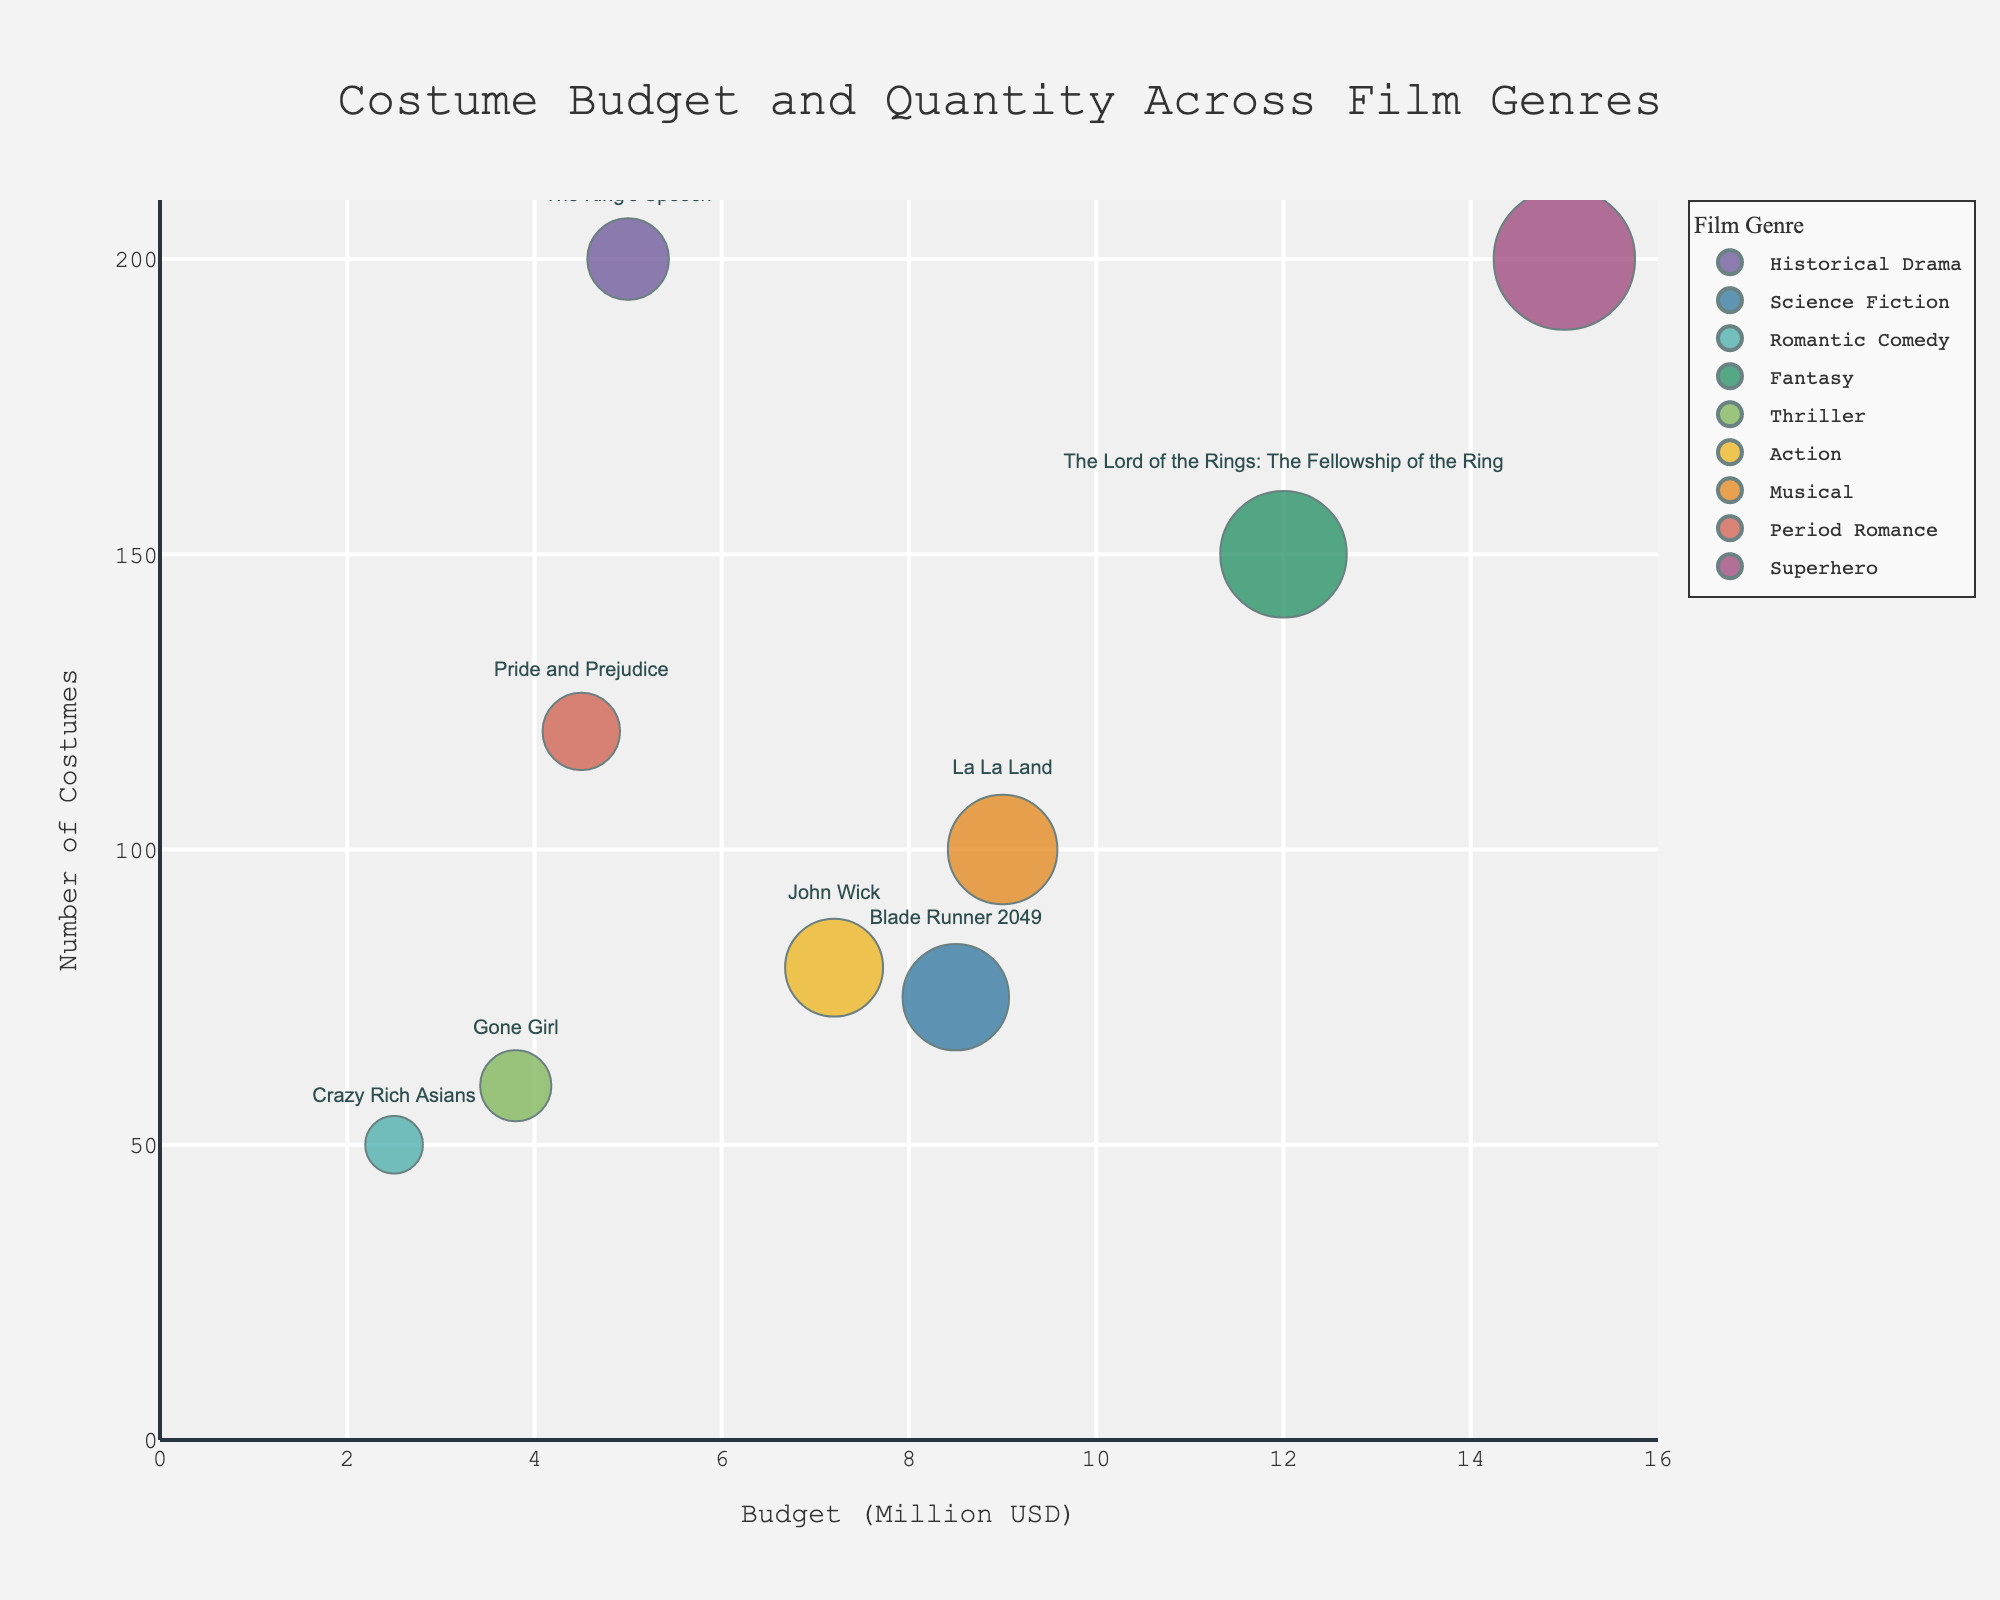What is the title of the chart? The title is usually placed at the top center of the chart and is meant to describe what the chart is about.
Answer: "Costume Budget and Quantity Across Film Genres" What are the x-axis and y-axis representing? The x-axis represents "Budget Allocation (in Million USD)" and the y-axis represents "Number of Costumes" as indicated by the axis titles.
Answer: Budget allocation and number of costumes How many film genres are displayed in the chart? Each distinct color represents a different film genre.
Answer: 9 Which film has the highest budget allocation? The size of the bubbles represents budget allocation; the largest bubble corresponds to "Avengers: Endgame."
Answer: Avengers: Endgame What is the number of costumes for "La La Land"? By looking at the bubble labeled "La La Land" on the y-axis, we can find the number of costumes.
Answer: 100 How does the number of costumes in "The Lord of the Rings: The Fellowship of the Ring" compare to "Blade Runner 2049"? Locate both bubbles on the y-axis and compare their values. "The Lord of the Rings: The Fellowship of the Ring" has more costumes (150 vs 75).
Answer: 150 vs 75 Which genre has the smallest bubble size and what does it indicate? The smallest bubble size represents the least budget allocation. The smallest bubble belongs to "Romantic Comedy" which is "Crazy Rich Asians" with 2.5 million USD.
Answer: Romantic Comedy What is the average number of costumes across all films? To find the average, sum up all the numbers of costumes and divide by the number of films. (200+75+50+150+60+80+100+120+200) / 9.
Answer: 115.6 Which film genres have exactly 200 costumes? Look for bubbles that align with the 200 mark on the y-axis. Both "Historical Drama" and "Superhero" genres have 200 costumes.
Answer: Historical Drama and Superhero Is the budget allocation for "John Wick" higher or lower than "Gone Girl"? Compare the x-axis positions of the bubbles labeled "John Wick" and "Gone Girl." "John Wick" is higher at 7.2 million USD vs 3.8 million USD for "Gone Girl."
Answer: Higher 